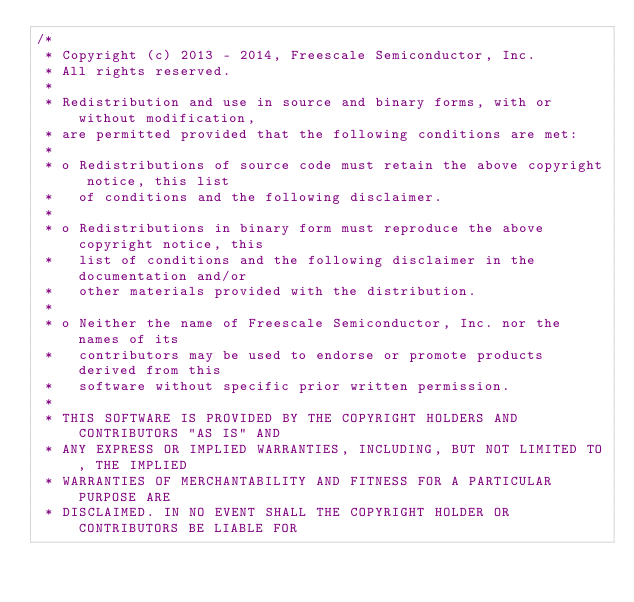<code> <loc_0><loc_0><loc_500><loc_500><_C_>/*
 * Copyright (c) 2013 - 2014, Freescale Semiconductor, Inc.
 * All rights reserved.
 *
 * Redistribution and use in source and binary forms, with or without modification,
 * are permitted provided that the following conditions are met:
 *
 * o Redistributions of source code must retain the above copyright notice, this list
 *   of conditions and the following disclaimer.
 *
 * o Redistributions in binary form must reproduce the above copyright notice, this
 *   list of conditions and the following disclaimer in the documentation and/or
 *   other materials provided with the distribution.
 *
 * o Neither the name of Freescale Semiconductor, Inc. nor the names of its
 *   contributors may be used to endorse or promote products derived from this
 *   software without specific prior written permission.
 *
 * THIS SOFTWARE IS PROVIDED BY THE COPYRIGHT HOLDERS AND CONTRIBUTORS "AS IS" AND
 * ANY EXPRESS OR IMPLIED WARRANTIES, INCLUDING, BUT NOT LIMITED TO, THE IMPLIED
 * WARRANTIES OF MERCHANTABILITY AND FITNESS FOR A PARTICULAR PURPOSE ARE
 * DISCLAIMED. IN NO EVENT SHALL THE COPYRIGHT HOLDER OR CONTRIBUTORS BE LIABLE FOR</code> 